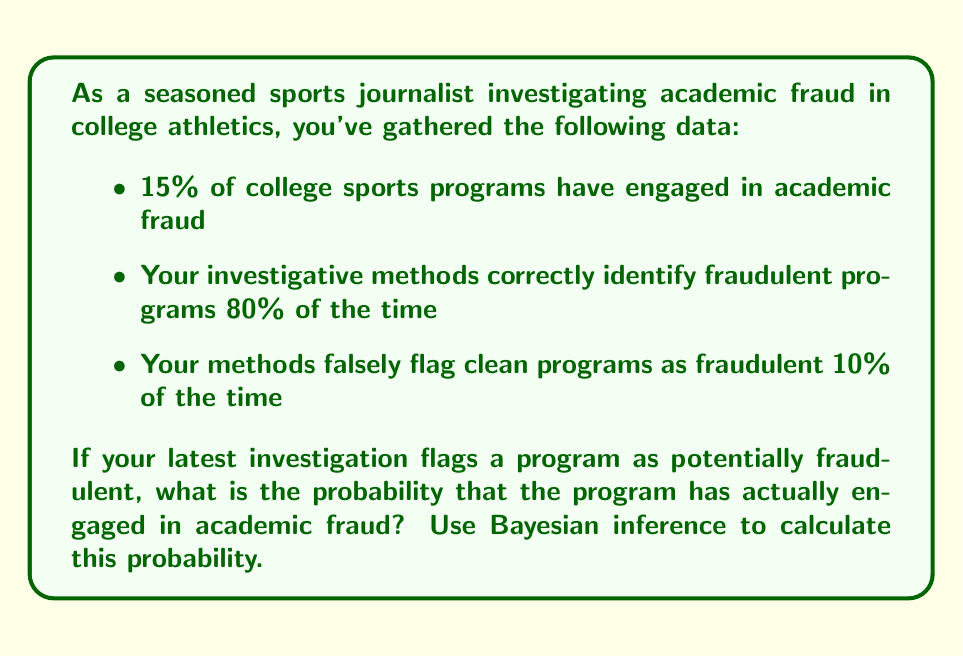Can you answer this question? Let's approach this problem using Bayesian inference:

1. Define our events:
   F: The program has engaged in academic fraud
   P: The program is flagged as potentially fraudulent

2. Given probabilities:
   P(F) = 0.15 (prior probability of fraud)
   P(P|F) = 0.80 (true positive rate)
   P(P|not F) = 0.10 (false positive rate)

3. We want to calculate P(F|P) using Bayes' theorem:

   $$P(F|P) = \frac{P(P|F) \cdot P(F)}{P(P)}$$

4. Calculate P(P) using the law of total probability:
   $$P(P) = P(P|F) \cdot P(F) + P(P|not F) \cdot P(not F)$$
   $$P(P) = 0.80 \cdot 0.15 + 0.10 \cdot 0.85 = 0.12 + 0.085 = 0.205$$

5. Now we can apply Bayes' theorem:
   $$P(F|P) = \frac{0.80 \cdot 0.15}{0.205} = \frac{0.12}{0.205} \approx 0.5854$$

6. Convert to a percentage:
   0.5854 * 100% ≈ 58.54%
Answer: 58.54% 